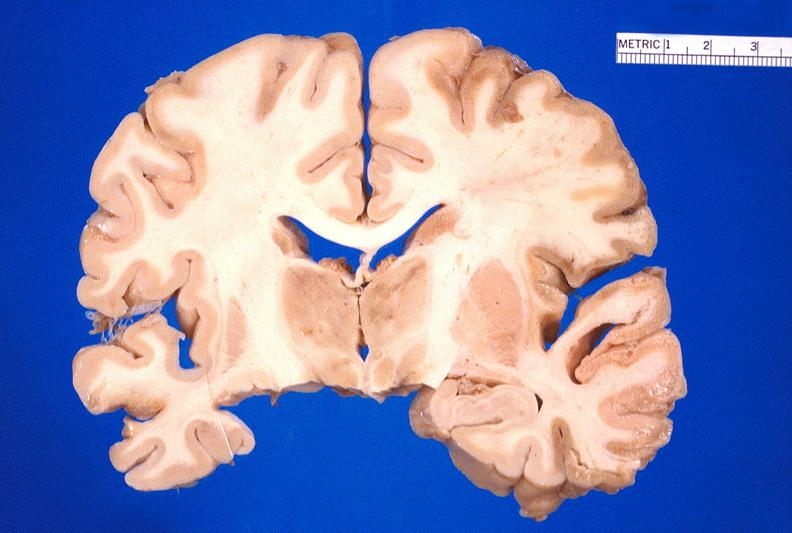s nervous present?
Answer the question using a single word or phrase. Yes 